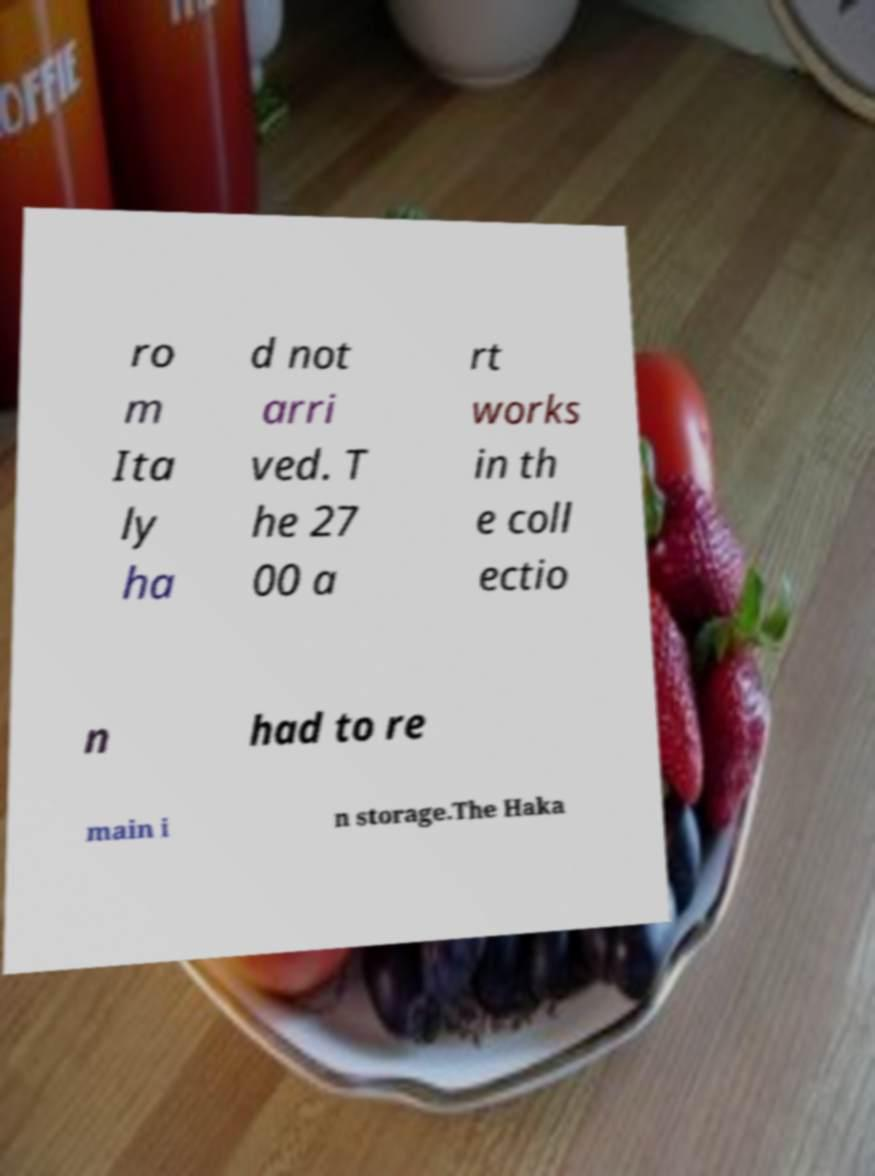I need the written content from this picture converted into text. Can you do that? ro m Ita ly ha d not arri ved. T he 27 00 a rt works in th e coll ectio n had to re main i n storage.The Haka 